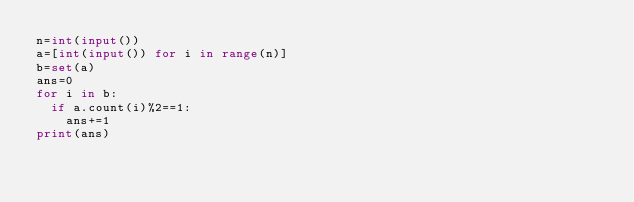<code> <loc_0><loc_0><loc_500><loc_500><_Python_>n=int(input())
a=[int(input()) for i in range(n)]
b=set(a)
ans=0
for i in b:
  if a.count(i)%2==1:
    ans+=1
print(ans)</code> 